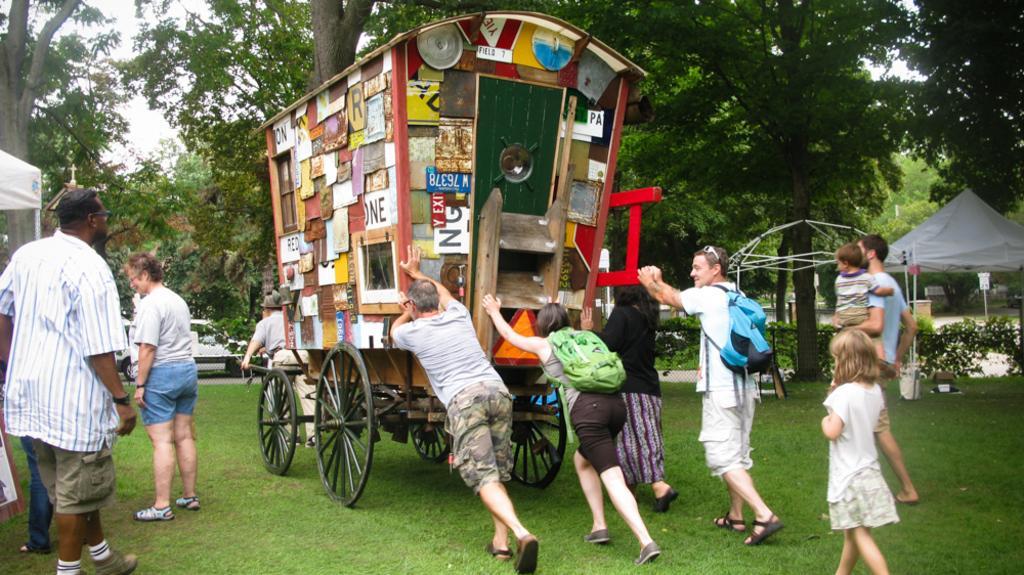In one or two sentences, can you explain what this image depicts? In this image we can see a few people, among them some people are pushing the cart, we can see some posters on the cart, there are some trees, poles, vehicles, plants, grass and a tent, in the background we can see the sky. 